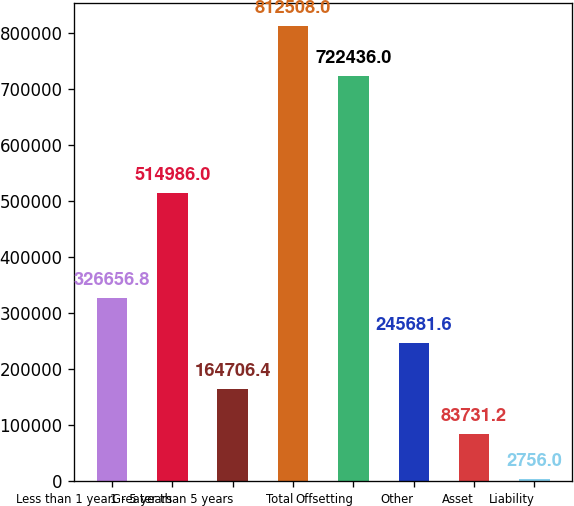<chart> <loc_0><loc_0><loc_500><loc_500><bar_chart><fcel>Less than 1 year<fcel>1 - 5 years<fcel>Greater than 5 years<fcel>Total<fcel>Offsetting<fcel>Other<fcel>Asset<fcel>Liability<nl><fcel>326657<fcel>514986<fcel>164706<fcel>812508<fcel>722436<fcel>245682<fcel>83731.2<fcel>2756<nl></chart> 